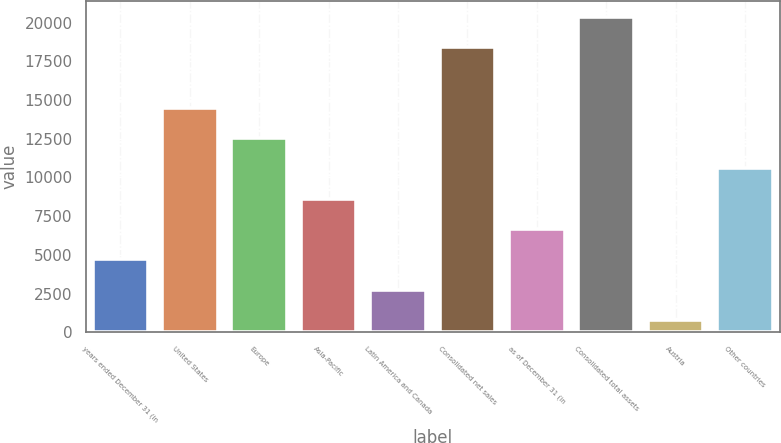Convert chart to OTSL. <chart><loc_0><loc_0><loc_500><loc_500><bar_chart><fcel>years ended December 31 (in<fcel>United States<fcel>Europe<fcel>Asia-Pacific<fcel>Latin America and Canada<fcel>Consolidated net sales<fcel>as of December 31 (in<fcel>Consolidated total assets<fcel>Austria<fcel>Other countries<nl><fcel>4719.6<fcel>14513.6<fcel>12554.8<fcel>8637.2<fcel>2760.8<fcel>18431.2<fcel>6678.4<fcel>20390<fcel>802<fcel>10596<nl></chart> 